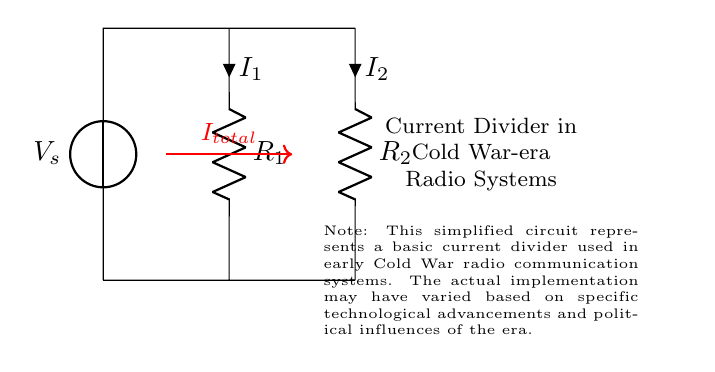What is the source voltage in the circuit? The source voltage is denoted as \( V_s \) located at the top of the circuit. It provides the necessary potential for the circuit's operation.
Answer: V_s What are the resistances in the current divider? The circuit has two resistances shown as \( R_1 \) and \( R_2 \). They are located vertically in the circuit, indicating that they are part of the current division process.
Answer: R_1, R_2 What is the relationship between total current and branch currents? The total current \( I_{total} \) splits into two branch currents \( I_1 \) and \( I_2 \) according to the resistances \( R_1 \) and \( R_2 \). This indicates that both currents are derived from the total current flowing from the source.
Answer: I_total = I_1 + I_2 Which resistor has the larger current if \( R_1 < R_2 \)? If \( R_1 \) is less than \( R_2 \), according to the current divider rule, the current through \( R_1 \) will be larger than that through \( R_2 \), since current inversely relates to resistance.
Answer: I_1 What is the purpose of using a current divider in radio communication systems? The purpose of using a current divider in radio communication systems is to control the distribution of current between different circuit elements, allowing for signal processing and amplification as needed in communication technology prevalent during the Cold War.
Answer: Current distribution 